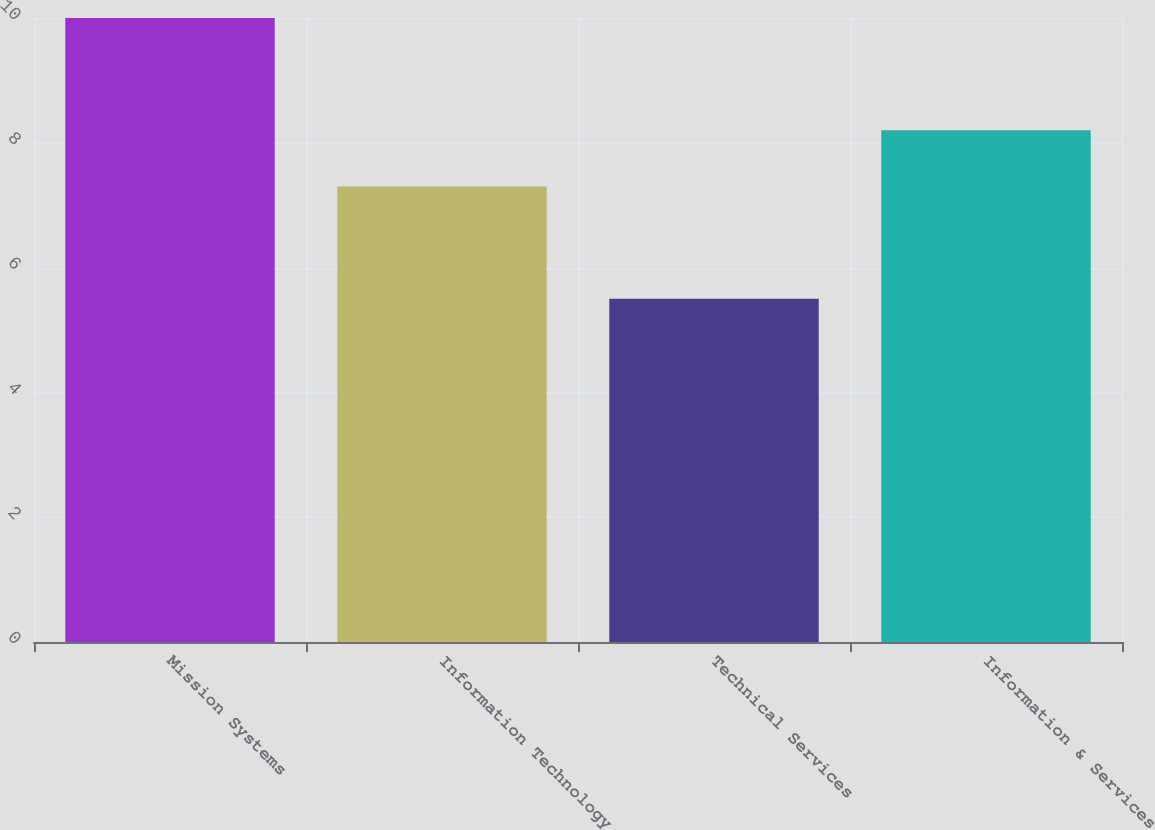Convert chart to OTSL. <chart><loc_0><loc_0><loc_500><loc_500><bar_chart><fcel>Mission Systems<fcel>Information Technology<fcel>Technical Services<fcel>Information & Services<nl><fcel>10<fcel>7.3<fcel>5.5<fcel>8.2<nl></chart> 